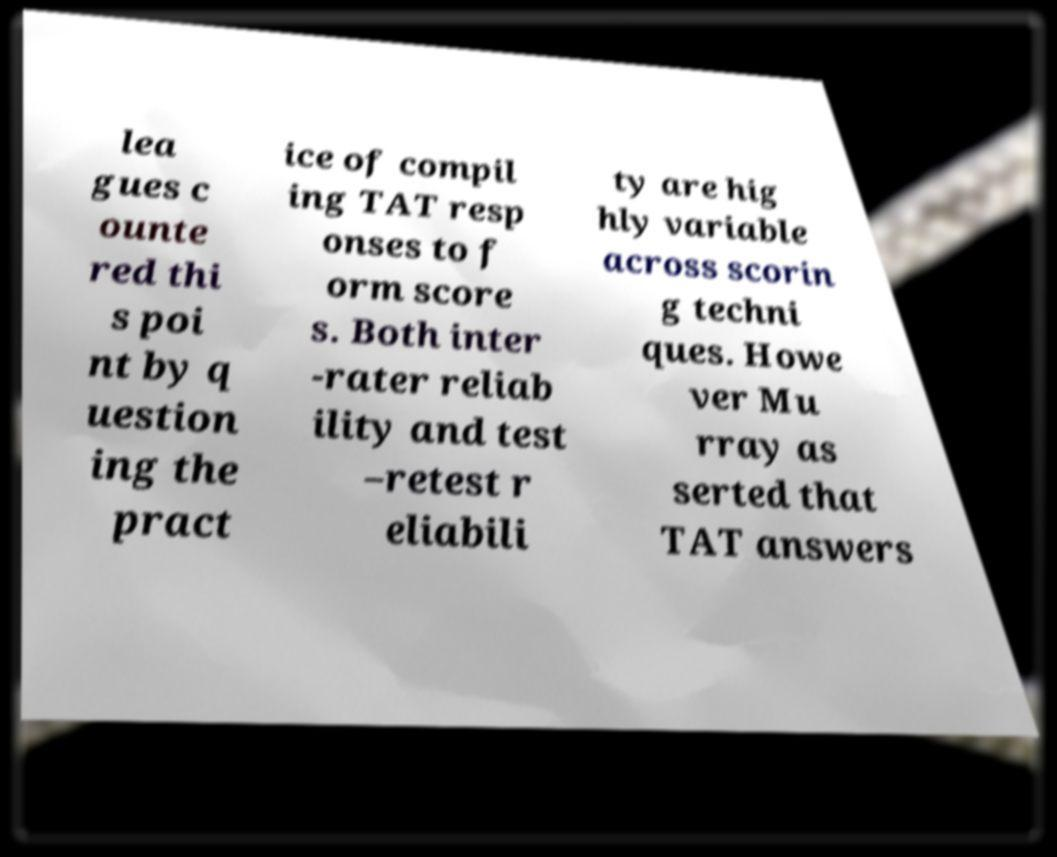What messages or text are displayed in this image? I need them in a readable, typed format. lea gues c ounte red thi s poi nt by q uestion ing the pract ice of compil ing TAT resp onses to f orm score s. Both inter -rater reliab ility and test –retest r eliabili ty are hig hly variable across scorin g techni ques. Howe ver Mu rray as serted that TAT answers 